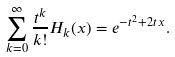<formula> <loc_0><loc_0><loc_500><loc_500>\sum _ { k = 0 } ^ { \infty } \frac { t ^ { k } } { k ! } H _ { k } ( x ) = e ^ { - t ^ { 2 } + 2 t \, x } .</formula> 